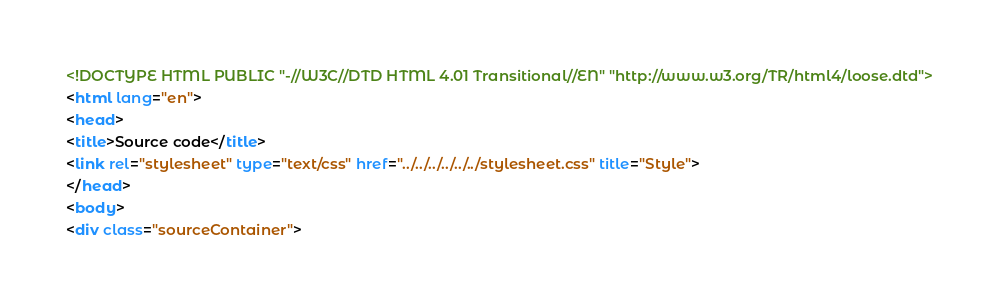<code> <loc_0><loc_0><loc_500><loc_500><_HTML_><!DOCTYPE HTML PUBLIC "-//W3C//DTD HTML 4.01 Transitional//EN" "http://www.w3.org/TR/html4/loose.dtd">
<html lang="en">
<head>
<title>Source code</title>
<link rel="stylesheet" type="text/css" href="../../../../../../stylesheet.css" title="Style">
</head>
<body>
<div class="sourceContainer"></code> 